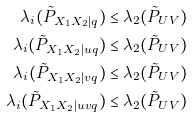Convert formula to latex. <formula><loc_0><loc_0><loc_500><loc_500>\lambda _ { i } ( \tilde { P } _ { X _ { 1 } X _ { 2 } | q } ) & \leq \lambda _ { 2 } ( \tilde { P } _ { U V } ) \\ \lambda _ { i } ( \tilde { P } _ { X _ { 1 } X _ { 2 } | u q } ) & \leq \lambda _ { 2 } ( \tilde { P } _ { U V } ) \\ \lambda _ { i } ( \tilde { P } _ { X _ { 1 } X _ { 2 } | v q } ) & \leq \lambda _ { 2 } ( \tilde { P } _ { U V } ) \\ \lambda _ { i } ( \tilde { P } _ { X _ { 1 } X _ { 2 } | u v q } ) & \leq \lambda _ { 2 } ( \tilde { P } _ { U V } )</formula> 